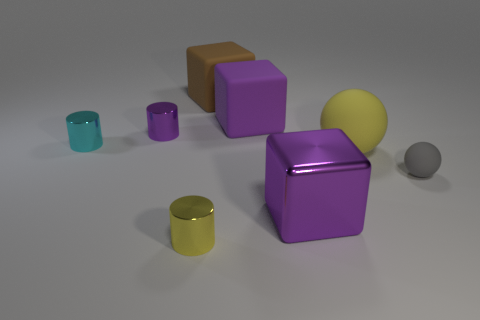Can you identify all the objects in the image by shape and color? Certainly! The image contains one yellow sphere, one large purple cube, two smaller purple cubes, one gray sphere, one brown cube, and three cylindrical objects—one cyan, one teal, and one yellow.  Which object seems to be closest to the front? The small yellow cylinder appears to be the closest object to the front of the image. 